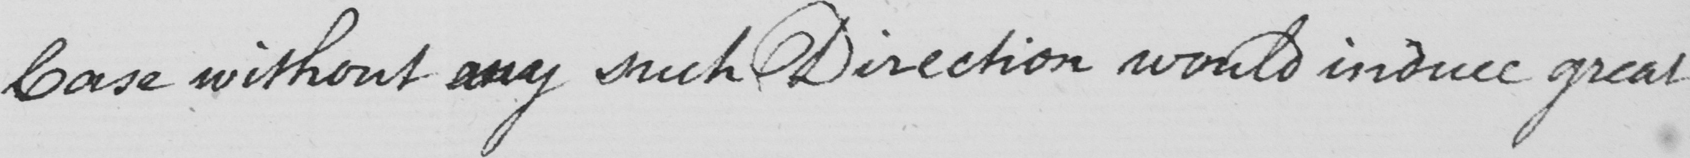What is written in this line of handwriting? Case without any such Direction would induce great 